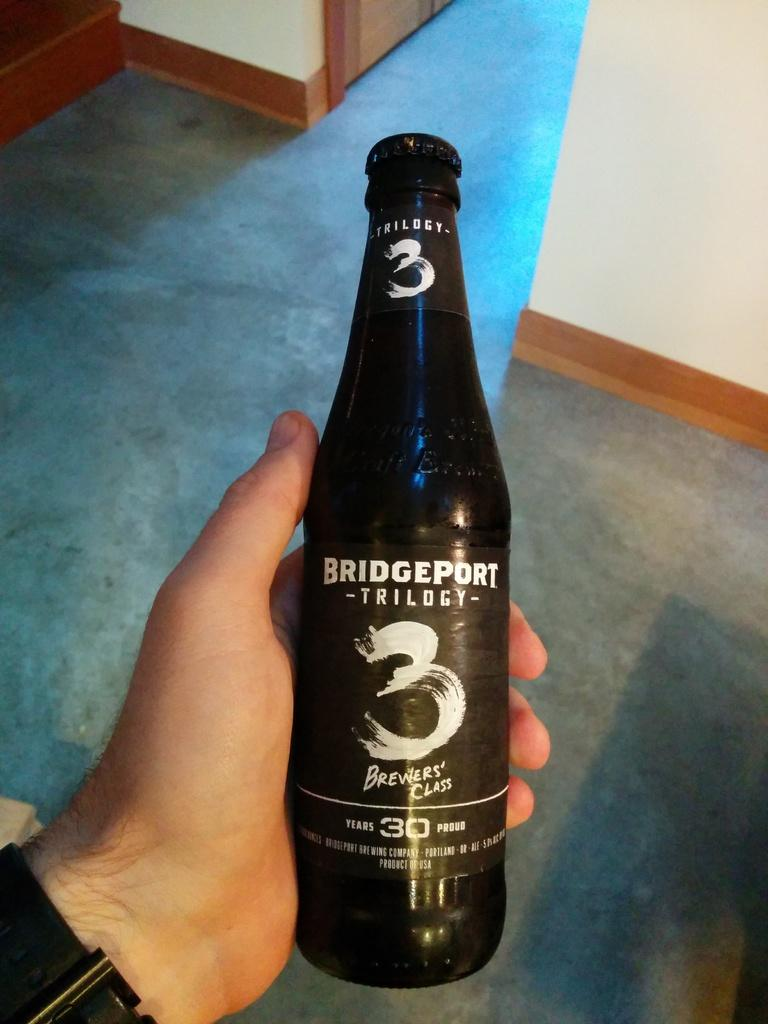<image>
Give a short and clear explanation of the subsequent image. Person holding a black beer bottle that says Bridgeport Trilogy on it. 